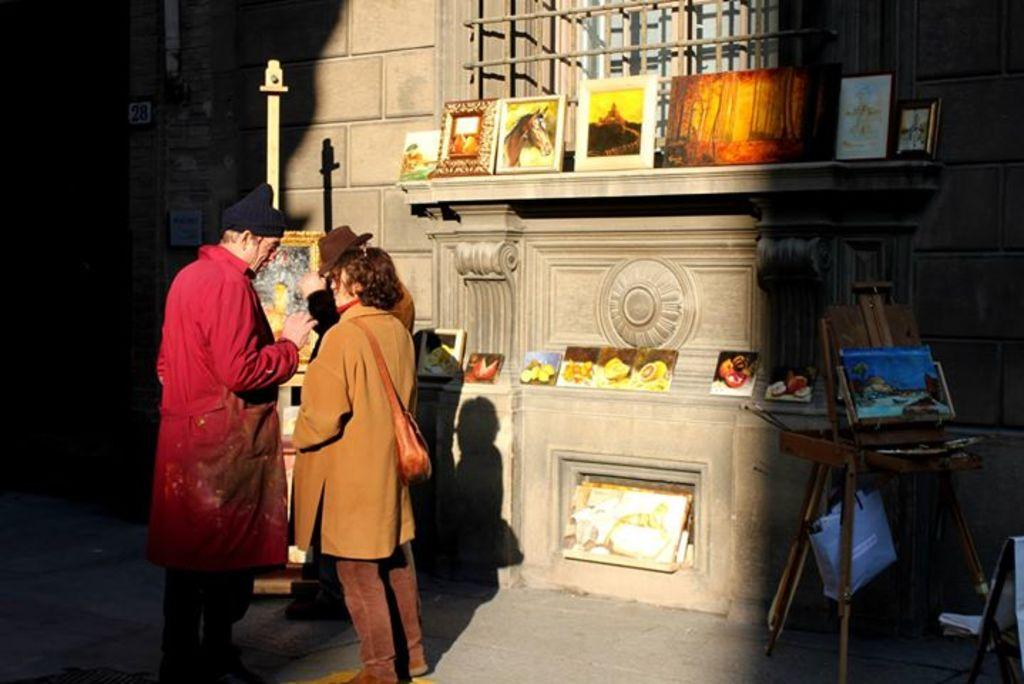How many people are in the image? There are two persons in the image. Where are the persons located in the image? The persons are standing on the road. What is visible in the background of the image? There is a wall in the image. What type of objects are present in the image? There are frames in the image. What type of joke is being told by the persons in the image? There is no indication in the image that the persons are telling a joke, so it cannot be determined from the picture. Is there any smoke visible in the image? There is no smoke present in the image. Do the persons in the image appear to have any regrets? There is no indication in the image that the persons have any regrets, as their expressions or body language cannot be observed. 